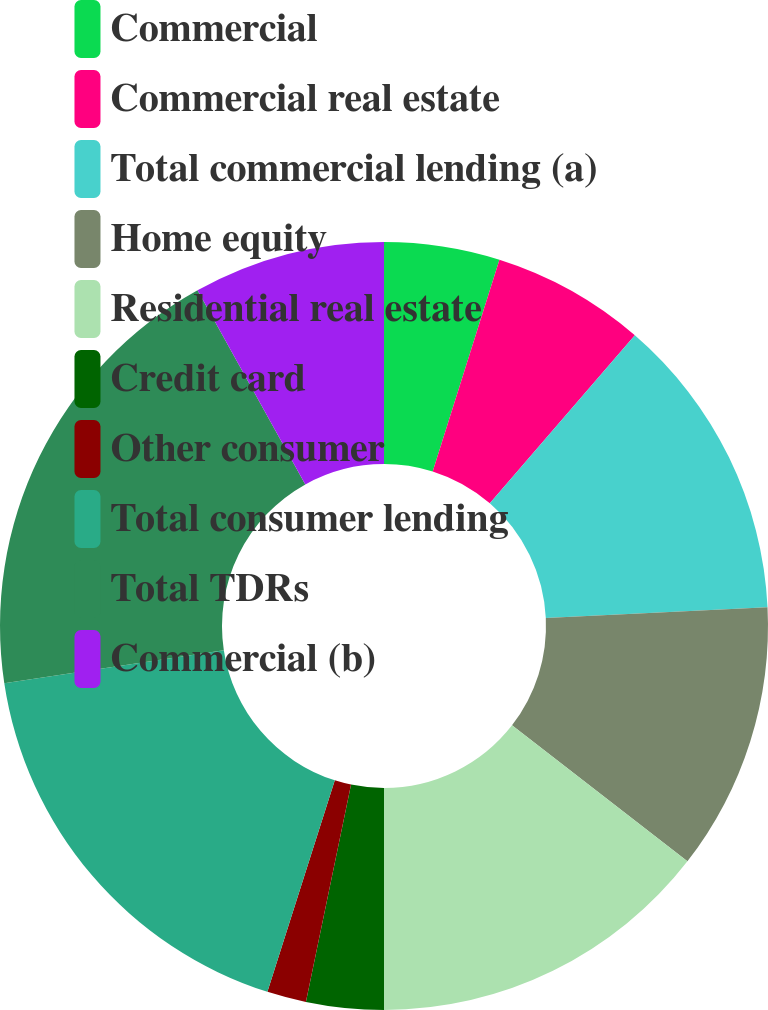Convert chart to OTSL. <chart><loc_0><loc_0><loc_500><loc_500><pie_chart><fcel>Commercial<fcel>Commercial real estate<fcel>Total commercial lending (a)<fcel>Home equity<fcel>Residential real estate<fcel>Credit card<fcel>Other consumer<fcel>Total consumer lending<fcel>Total TDRs<fcel>Commercial (b)<nl><fcel>4.86%<fcel>6.47%<fcel>12.89%<fcel>11.28%<fcel>14.5%<fcel>3.26%<fcel>1.65%<fcel>17.71%<fcel>19.31%<fcel>8.07%<nl></chart> 